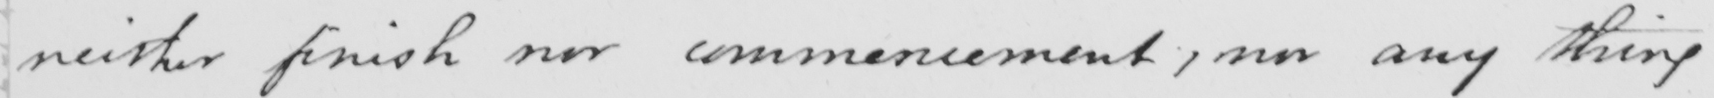What does this handwritten line say? neither finish nor commencement , nor any thing 